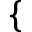Convert formula to latex. <formula><loc_0><loc_0><loc_500><loc_500>\{</formula> 